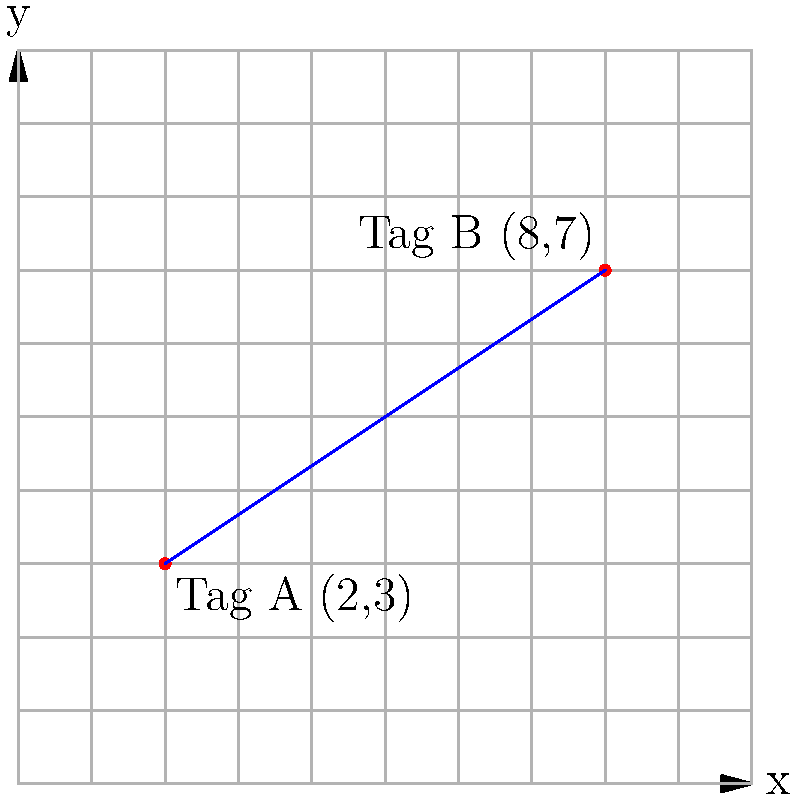You've just finished tagging two spots in the city and need to calculate the distance between them to plan your escape route. Tag A is located at coordinates (2,3) and Tag B is at (8,7) on the city grid. Using the distance formula, determine the straight-line distance between these two tags. Round your answer to two decimal places. To find the distance between two points on a coordinate plane, we use the distance formula:

$$d = \sqrt{(x_2 - x_1)^2 + (y_2 - y_1)^2}$$

Where $(x_1, y_1)$ are the coordinates of the first point and $(x_2, y_2)$ are the coordinates of the second point.

Given:
- Tag A: $(x_1, y_1) = (2, 3)$
- Tag B: $(x_2, y_2) = (8, 7)$

Let's plug these values into the formula:

$$d = \sqrt{(8 - 2)^2 + (7 - 3)^2}$$

Simplify:
$$d = \sqrt{6^2 + 4^2}$$

Calculate the squares:
$$d = \sqrt{36 + 16}$$

Add under the square root:
$$d = \sqrt{52}$$

Calculate the square root:
$$d \approx 7.21$$

Rounding to two decimal places:
$$d \approx 7.21$$

Therefore, the straight-line distance between Tag A and Tag B is approximately 7.21 units on the city grid.
Answer: 7.21 units 